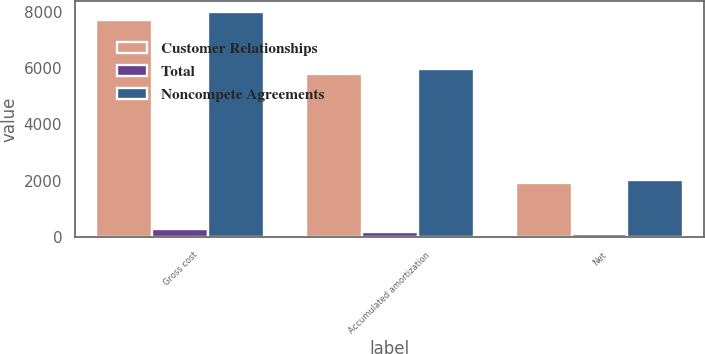<chart> <loc_0><loc_0><loc_500><loc_500><stacked_bar_chart><ecel><fcel>Gross cost<fcel>Accumulated amortization<fcel>Net<nl><fcel>Customer Relationships<fcel>7700<fcel>5775<fcel>1925<nl><fcel>Total<fcel>278<fcel>188<fcel>90<nl><fcel>Noncompete Agreements<fcel>7978<fcel>5963<fcel>2015<nl></chart> 